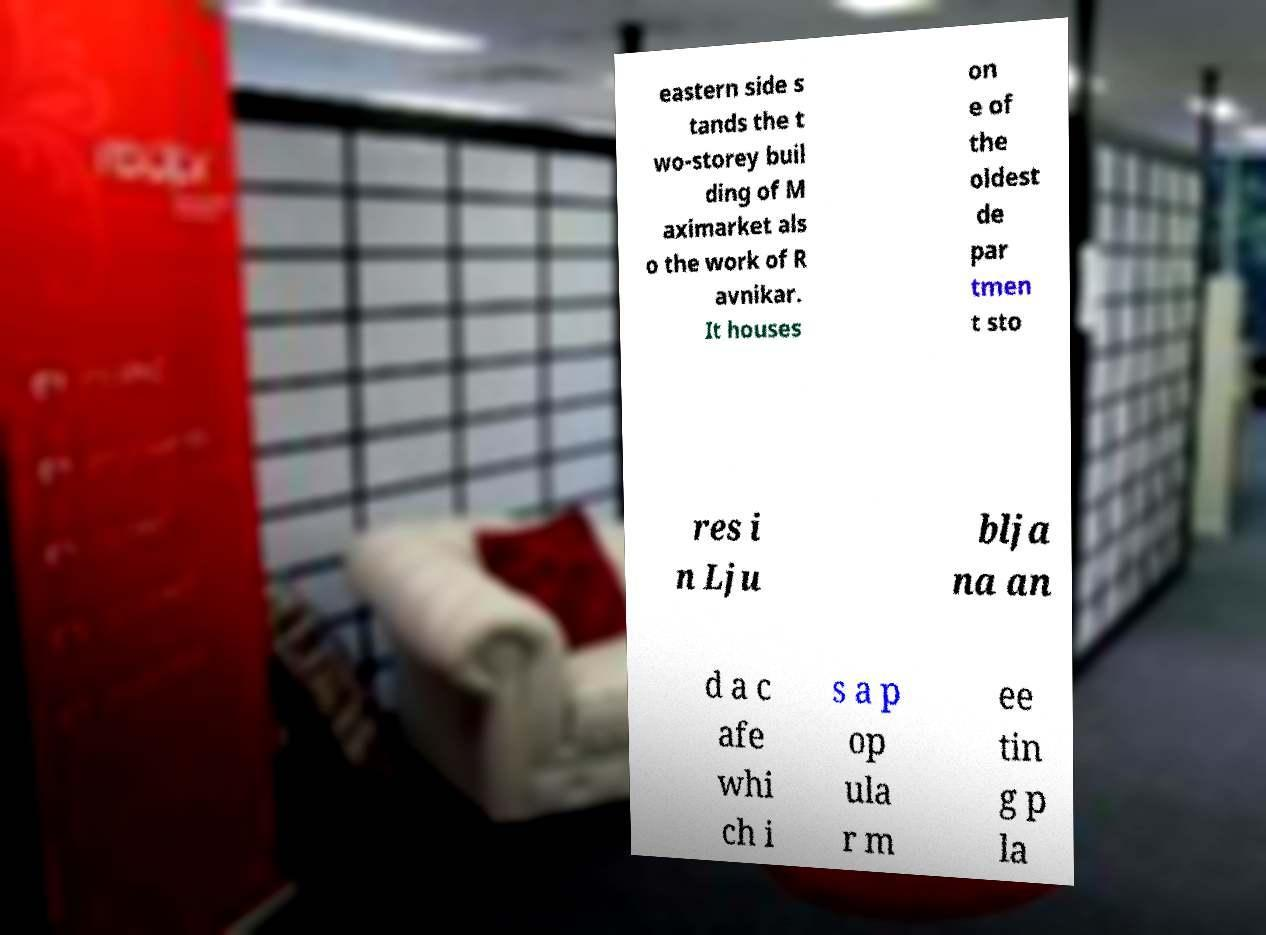Could you assist in decoding the text presented in this image and type it out clearly? eastern side s tands the t wo-storey buil ding of M aximarket als o the work of R avnikar. It houses on e of the oldest de par tmen t sto res i n Lju blja na an d a c afe whi ch i s a p op ula r m ee tin g p la 